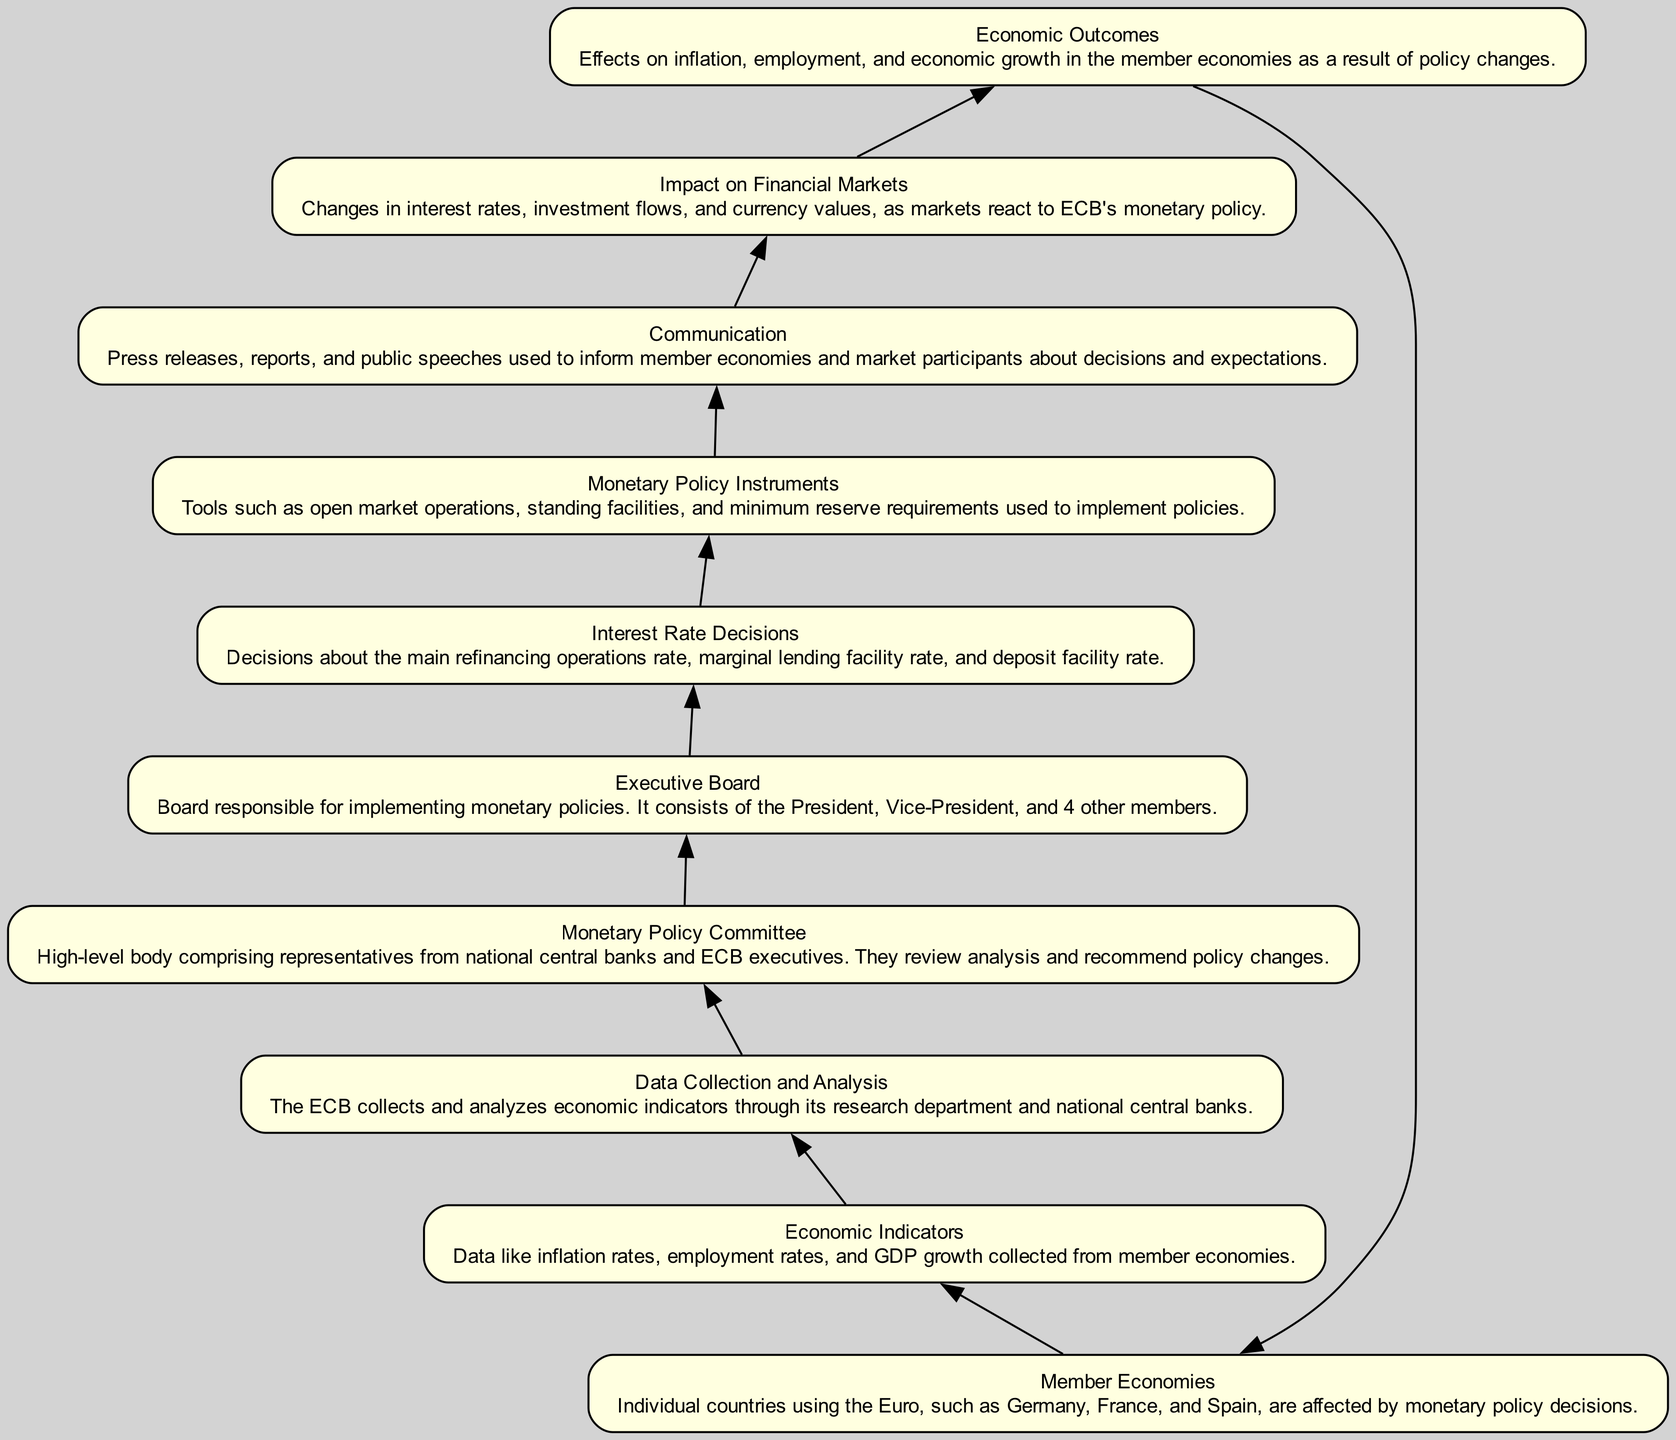What is the top node in the flow chart? The top node in the flow chart represents "Member Economies," which is the starting point where the effects of monetary policy decisions are observed.
Answer: Member Economies How many nodes are in the diagram? The diagram features a total of ten nodes, each representing a distinct component of the ECB's monetary policy process.
Answer: Ten What follows the "Interest Rate Decisions" node? After "Interest Rate Decisions," the flow indicates that the subsequent node is "Monetary Policy Instruments," which represents the tools used to implement the policy decisions.
Answer: Monetary Policy Instruments Which node directly impacts the "Economic Outcomes"? The "Impact on Financial Markets" node directly affects the "Economic Outcomes," indicating how monetary policy translates into results for member economies.
Answer: Impact on Financial Markets What is the relationship between "Communication" and "Impact on Financial Markets"? "Communication" influences "Impact on Financial Markets" by disseminating information about monetary policy decisions, which in turn affects how markets react.
Answer: Influences Which element collects and analyzes economic indicators? The "Data Collection and Analysis" element is responsible for gathering and interpreting economic indicators from various member economies.
Answer: Data Collection and Analysis Explain the flow from "Executive Board" to "Impact on Financial Markets." Following the "Executive Board," the flow moves to "Interest Rate Decisions," which shapes "Monetary Policy Instruments." These instruments, communicated to the public and markets, eventually lead to changes observed in "Impact on Financial Markets." Each step shows how decisions influence financial conditions.
Answer: See explanation What role do "Economic Indicators" play in the flow? "Economic Indicators" are crucial as they initiate the process by providing foundational data that informs subsequent analysis and decision-making throughout the ECB's policy structure.
Answer: Foundational data Which element is the last step in the flow before returning to "Member Economies"? The final step before circling back to "Member Economies" is "Economic Outcomes," highlighting the end results of the monetary policy process.
Answer: Economic Outcomes 